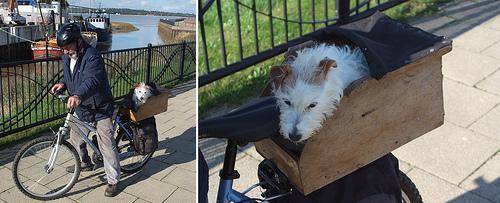How many people in picture?
Give a very brief answer. 1. 